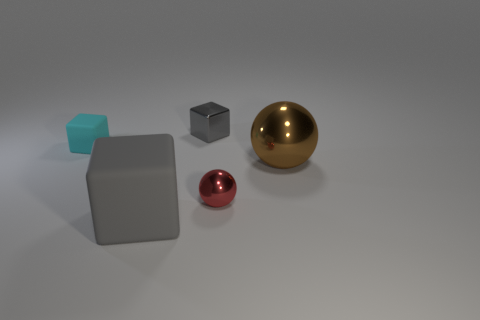How many blocks are the same material as the tiny red object?
Provide a succinct answer. 1. What size is the shiny thing that is behind the brown object?
Your answer should be compact. Small. There is a small metal thing in front of the small gray shiny cube behind the tiny sphere; what is its shape?
Your answer should be compact. Sphere. How many tiny objects are behind the sphere that is to the right of the shiny object in front of the brown shiny ball?
Provide a succinct answer. 2. Are there fewer tiny things that are left of the tiny rubber cube than big purple matte blocks?
Your response must be concise. No. Is there anything else that is the same shape as the big rubber object?
Your answer should be compact. Yes. There is a shiny object that is on the left side of the tiny red metallic sphere; what is its shape?
Keep it short and to the point. Cube. The small object in front of the object to the left of the matte object that is to the right of the small cyan rubber block is what shape?
Offer a terse response. Sphere. What number of objects are either brown balls or small red balls?
Your response must be concise. 2. There is a matte thing that is behind the gray matte cube; does it have the same shape as the gray object in front of the gray shiny thing?
Offer a terse response. Yes. 